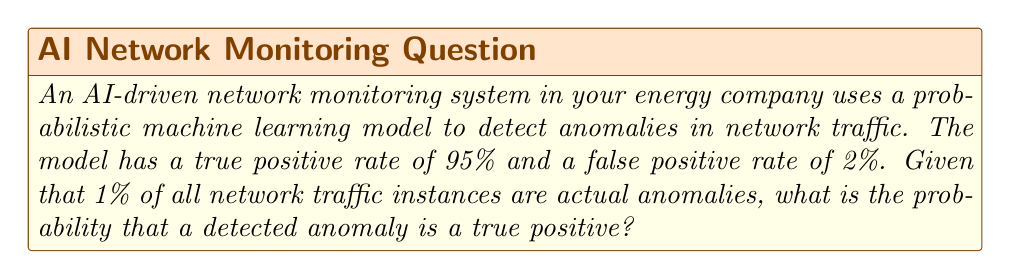Teach me how to tackle this problem. To solve this problem, we'll use Bayes' theorem. Let's define our events:

A: The instance is an actual anomaly
D: The instance is detected as an anomaly

We're given:
P(A) = 0.01 (1% of all instances are actual anomalies)
P(D|A) = 0.95 (95% true positive rate)
P(D|not A) = 0.02 (2% false positive rate)

We want to find P(A|D), the probability that a detected anomaly is a true positive.

Bayes' theorem states:

$$ P(A|D) = \frac{P(D|A) \cdot P(A)}{P(D)} $$

To find P(D), we use the law of total probability:

$$ P(D) = P(D|A) \cdot P(A) + P(D|not A) \cdot P(not A) $$

Step 1: Calculate P(not A)
P(not A) = 1 - P(A) = 1 - 0.01 = 0.99

Step 2: Calculate P(D)
$$ P(D) = 0.95 \cdot 0.01 + 0.02 \cdot 0.99 = 0.0095 + 0.0198 = 0.0293 $$

Step 3: Apply Bayes' theorem
$$ P(A|D) = \frac{0.95 \cdot 0.01}{0.0293} \approx 0.3242 $$

Therefore, the probability that a detected anomaly is a true positive is approximately 0.3242 or 32.42%.
Answer: 0.3242 (or 32.42%) 